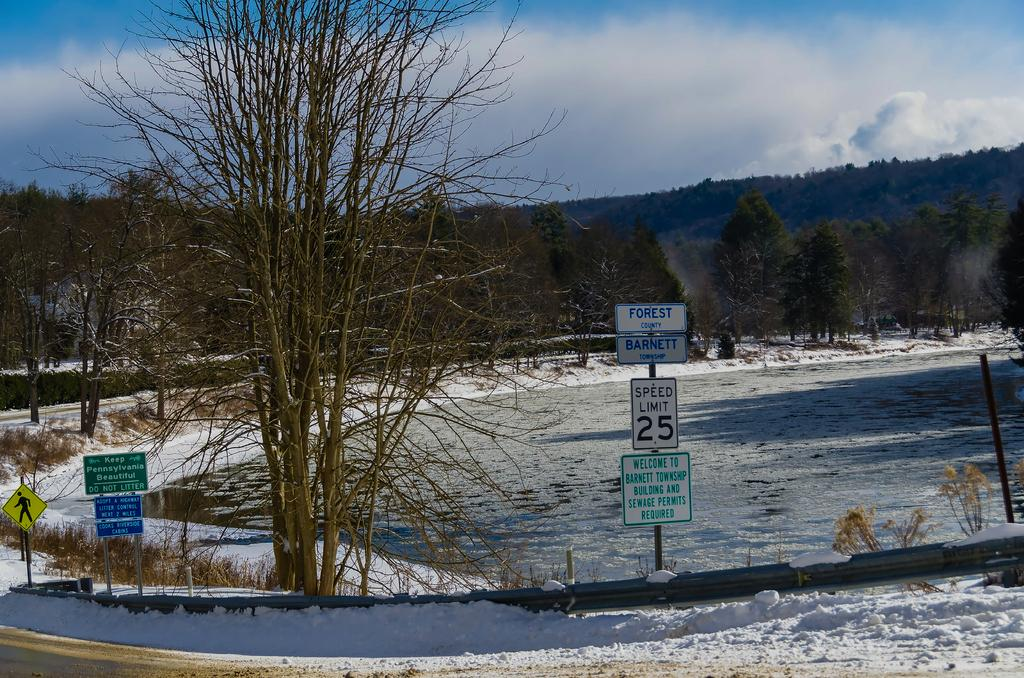What is the primary weather condition depicted in the image? There is snow in the image. What type of natural features can be seen in the image? There are trees and hills in the image. What man-made object is present in the image? There is a signboard in the image. What is visible in the sky in the image? The sky is visible in the image, and clouds are present. What type of news can be seen on the signboard in the image? There is no news present on the signboard in the image; it is not mentioned in the provided facts. Can you tell me how many kittens are playing on the hills in the image? There are no kittens present in the image; only snow, trees, hills, a signboard, and clouds are mentioned. 